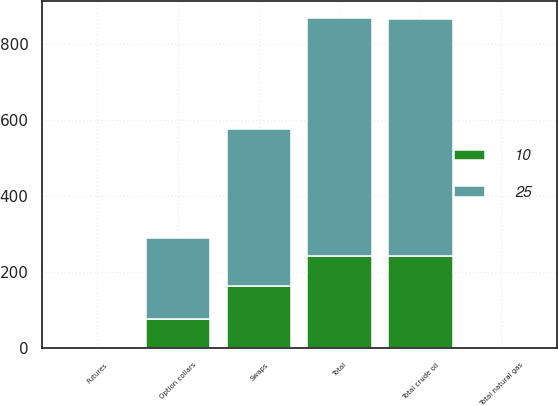Convert chart. <chart><loc_0><loc_0><loc_500><loc_500><stacked_bar_chart><ecel><fcel>Swaps<fcel>Option collars<fcel>Total crude oil<fcel>Futures<fcel>Total natural gas<fcel>Total<nl><fcel>10<fcel>165<fcel>77<fcel>242<fcel>1<fcel>1<fcel>243<nl><fcel>25<fcel>412<fcel>212<fcel>624<fcel>2<fcel>2<fcel>626<nl></chart> 